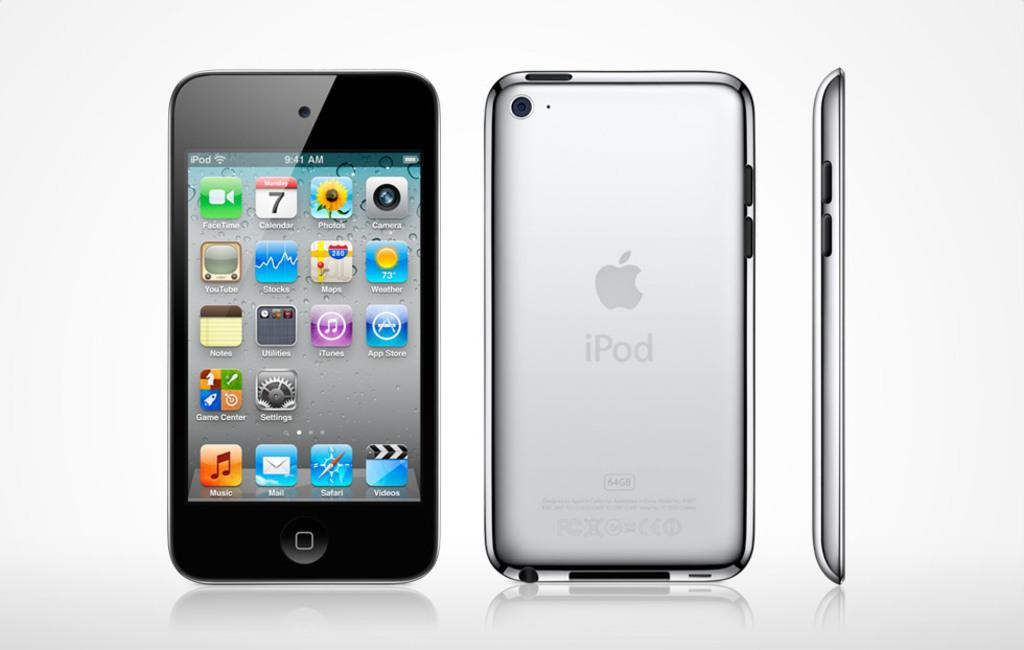What is the main subject of the image? The main subject of the image is a mobile phone. How many views of the mobile phone are shown in the image? The image shows the front view, back view, and side view of a mobile phone. What is the color of the background in the image? The background of the image is white in color. What type of cub can be seen playing with the mobile phone in the image? There is no cub present in the image, and the mobile phone is not being played with. 